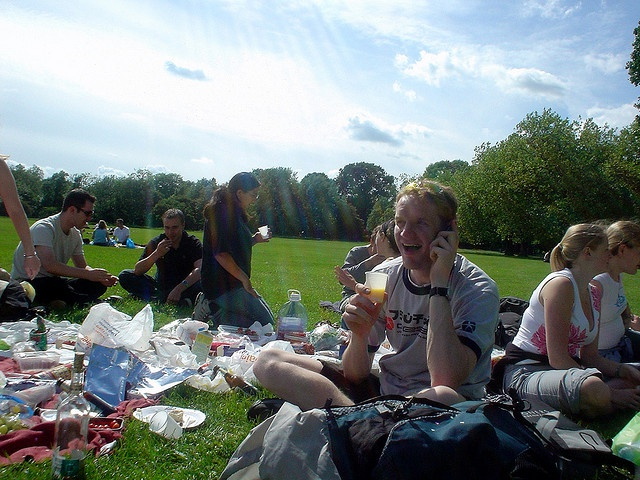Describe the objects in this image and their specific colors. I can see people in lavender, black, gray, and maroon tones, backpack in lavender, black, gray, blue, and darkblue tones, people in lavender, black, gray, and darkgray tones, people in lavender, black, gray, maroon, and blue tones, and people in lavender, black, gray, and darkgreen tones in this image. 